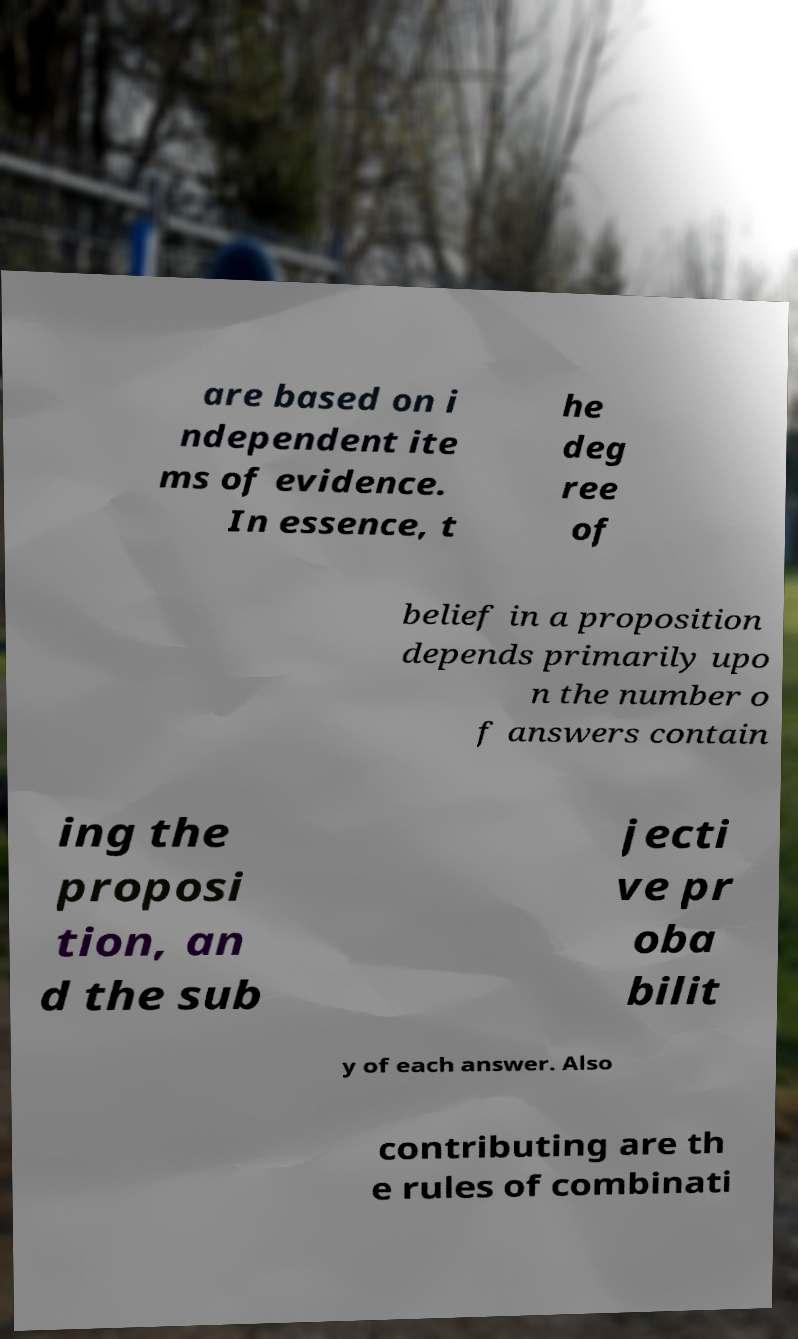What messages or text are displayed in this image? I need them in a readable, typed format. are based on i ndependent ite ms of evidence. In essence, t he deg ree of belief in a proposition depends primarily upo n the number o f answers contain ing the proposi tion, an d the sub jecti ve pr oba bilit y of each answer. Also contributing are th e rules of combinati 